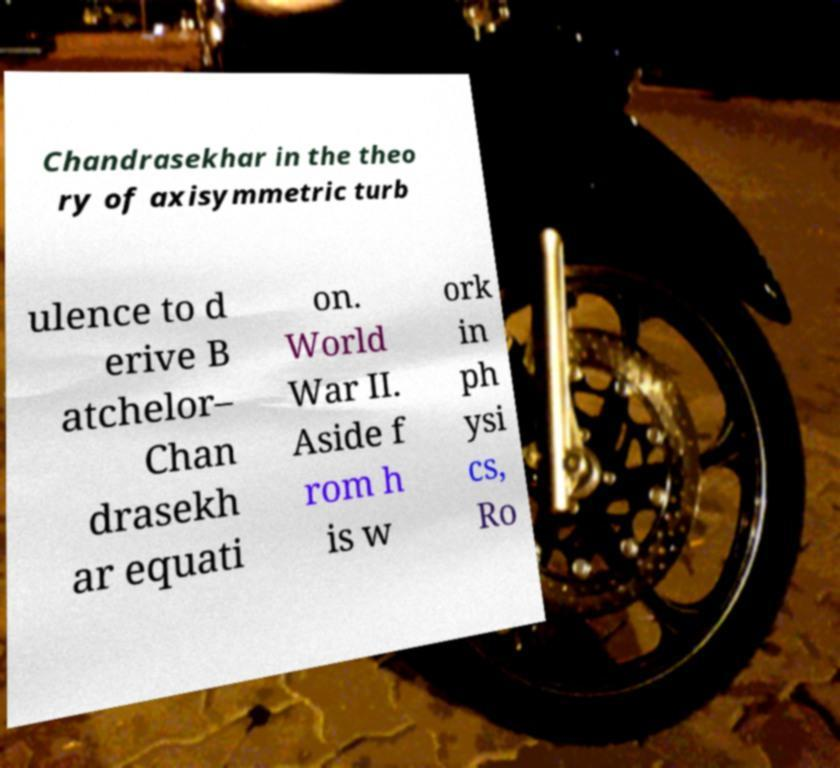Can you accurately transcribe the text from the provided image for me? Chandrasekhar in the theo ry of axisymmetric turb ulence to d erive B atchelor– Chan drasekh ar equati on. World War II. Aside f rom h is w ork in ph ysi cs, Ro 